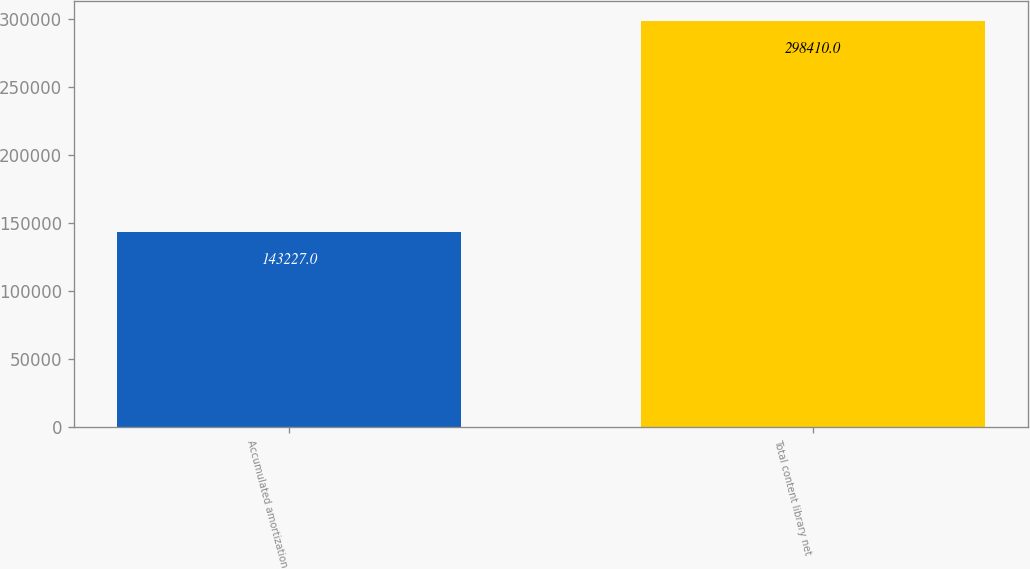Convert chart. <chart><loc_0><loc_0><loc_500><loc_500><bar_chart><fcel>Accumulated amortization<fcel>Total content library net<nl><fcel>143227<fcel>298410<nl></chart> 